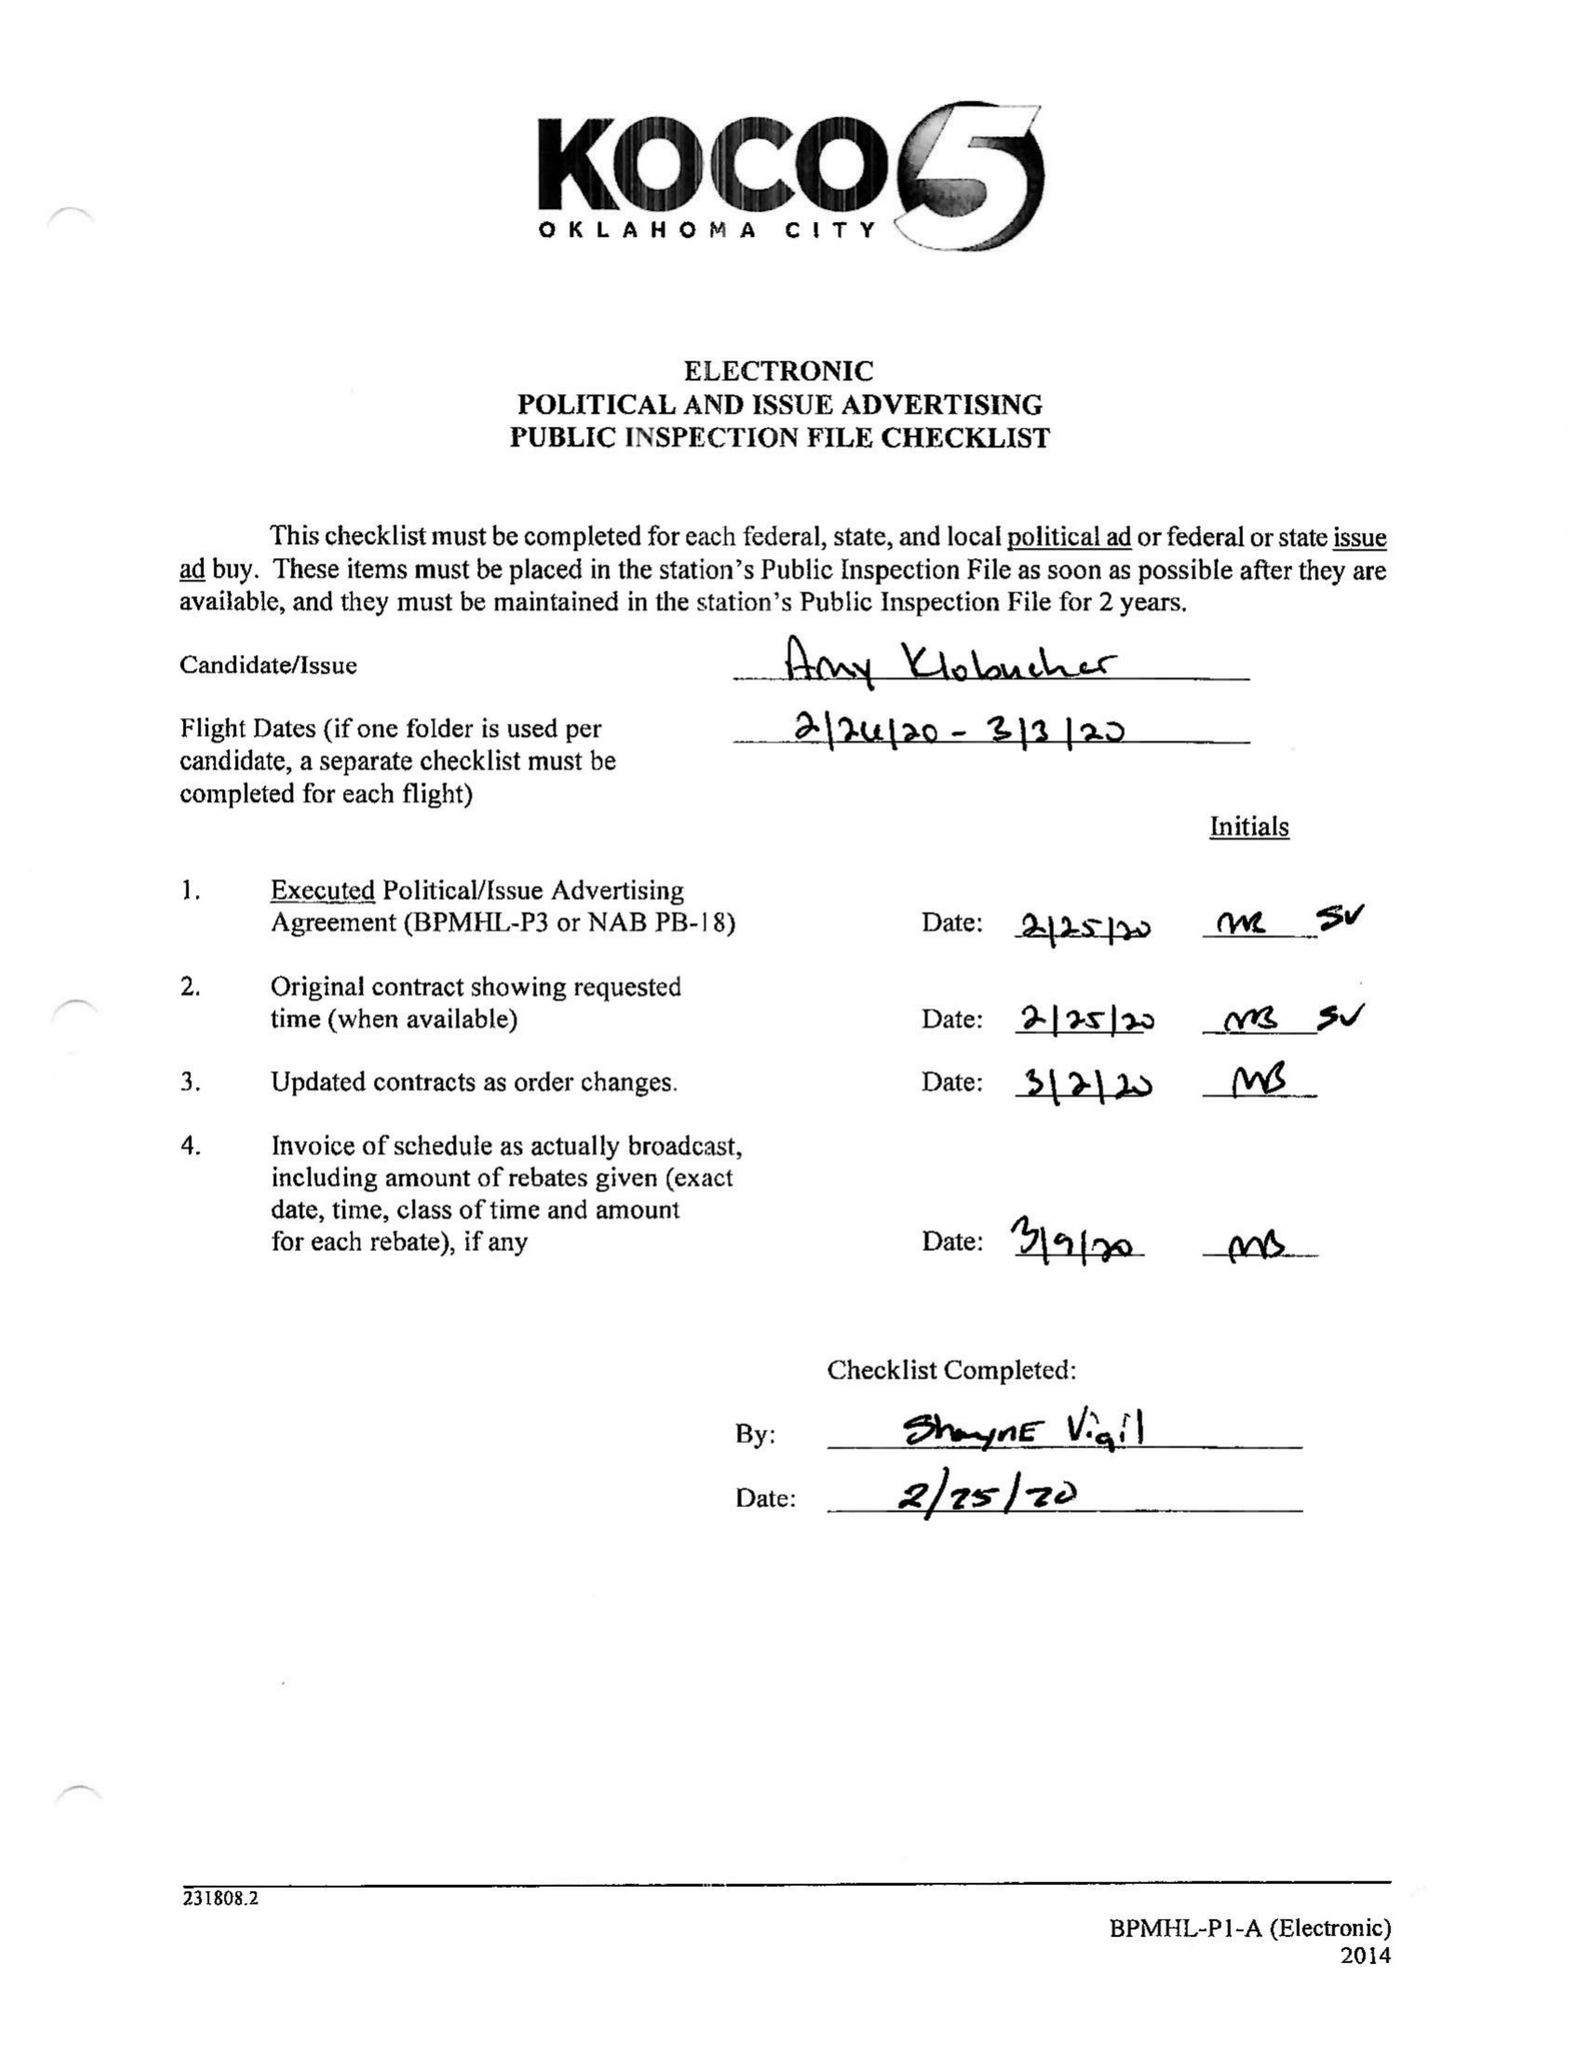What is the value for the contract_num?
Answer the question using a single word or phrase. 1985860 